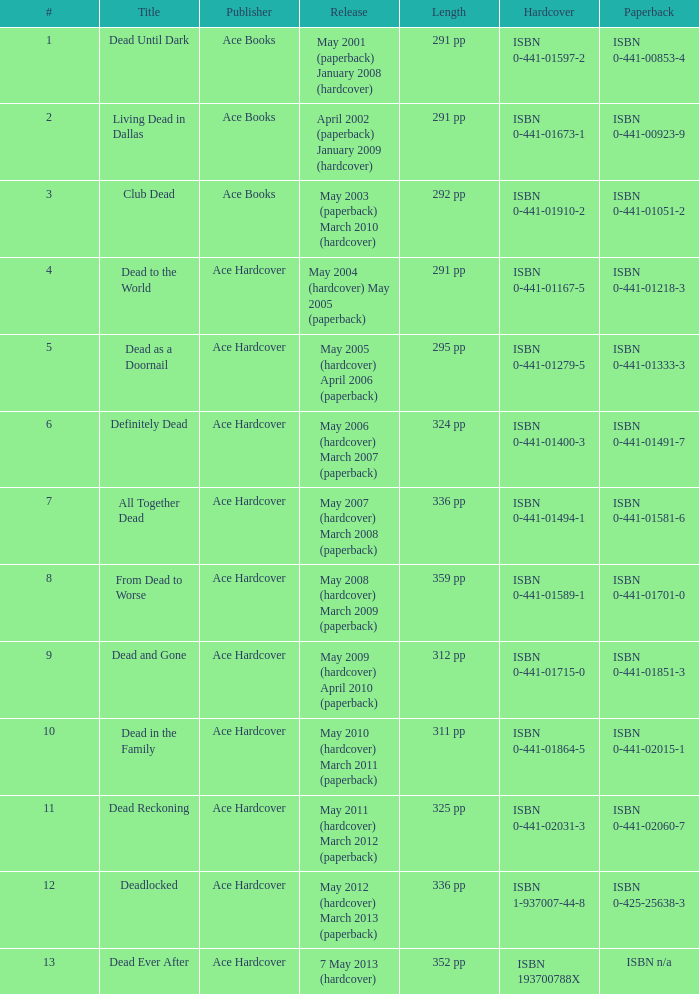Isbn 0-441-01400-3 is book number? 6.0. 